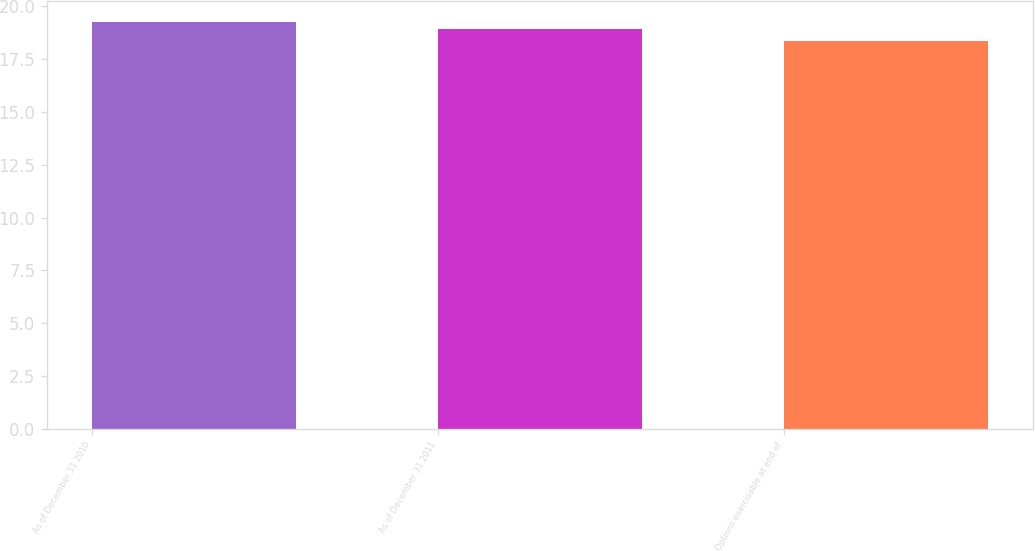Convert chart. <chart><loc_0><loc_0><loc_500><loc_500><bar_chart><fcel>As of December 31 2010<fcel>As of December 31 2011<fcel>Options exercisable at end of<nl><fcel>19.27<fcel>18.94<fcel>18.37<nl></chart> 